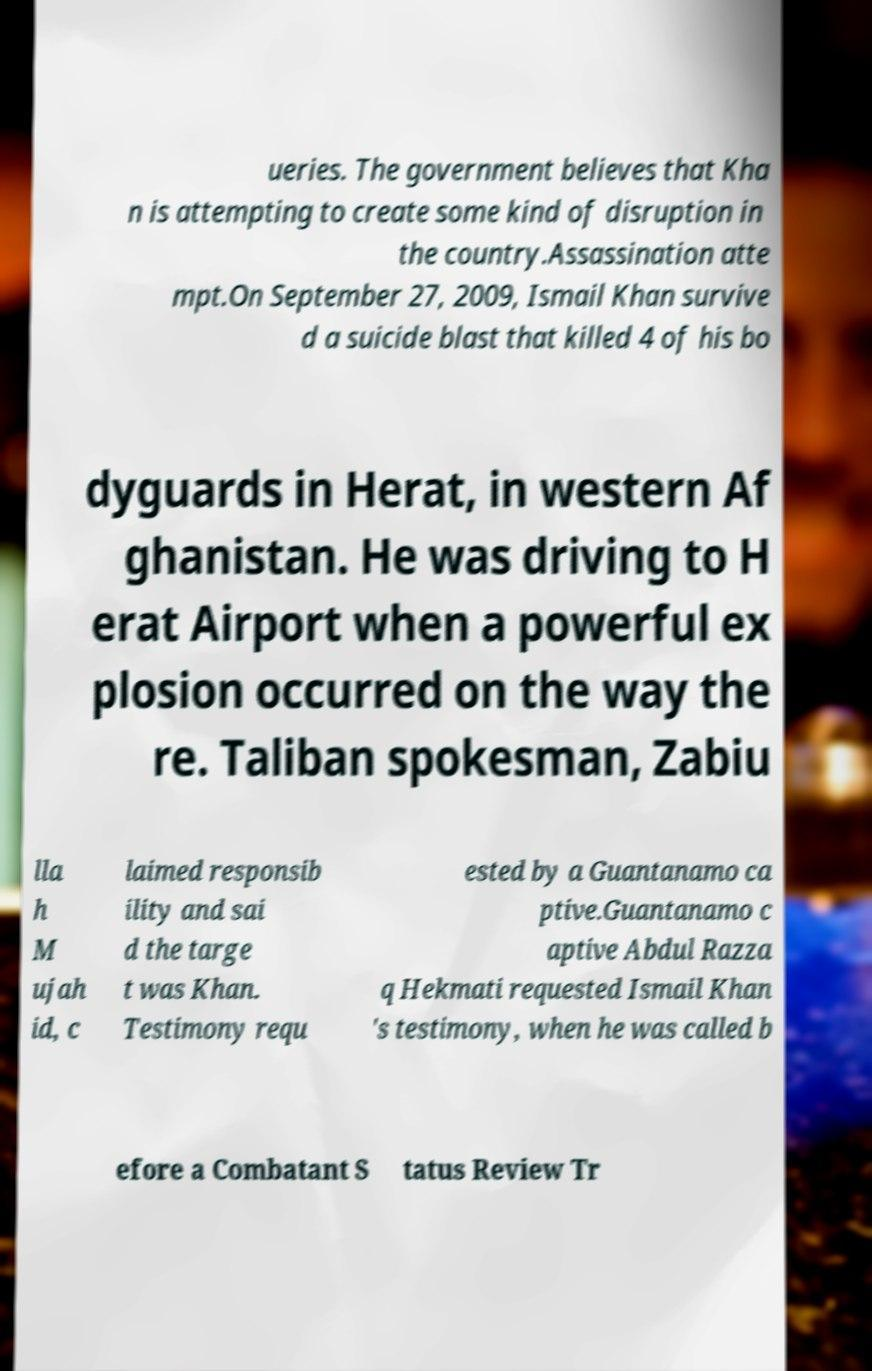Please identify and transcribe the text found in this image. ueries. The government believes that Kha n is attempting to create some kind of disruption in the country.Assassination atte mpt.On September 27, 2009, Ismail Khan survive d a suicide blast that killed 4 of his bo dyguards in Herat, in western Af ghanistan. He was driving to H erat Airport when a powerful ex plosion occurred on the way the re. Taliban spokesman, Zabiu lla h M ujah id, c laimed responsib ility and sai d the targe t was Khan. Testimony requ ested by a Guantanamo ca ptive.Guantanamo c aptive Abdul Razza q Hekmati requested Ismail Khan 's testimony, when he was called b efore a Combatant S tatus Review Tr 